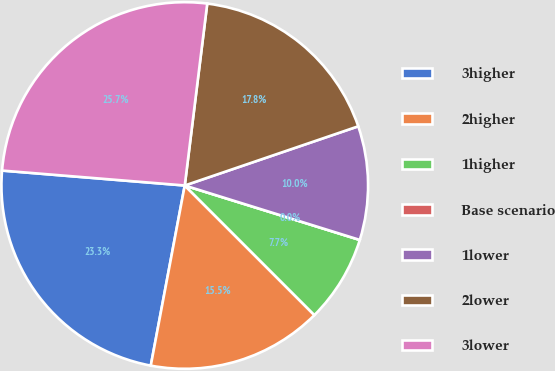Convert chart. <chart><loc_0><loc_0><loc_500><loc_500><pie_chart><fcel>3higher<fcel>2higher<fcel>1higher<fcel>Base scenario<fcel>1lower<fcel>2lower<fcel>3lower<nl><fcel>23.33%<fcel>15.47%<fcel>7.7%<fcel>0.0%<fcel>10.03%<fcel>17.81%<fcel>25.66%<nl></chart> 